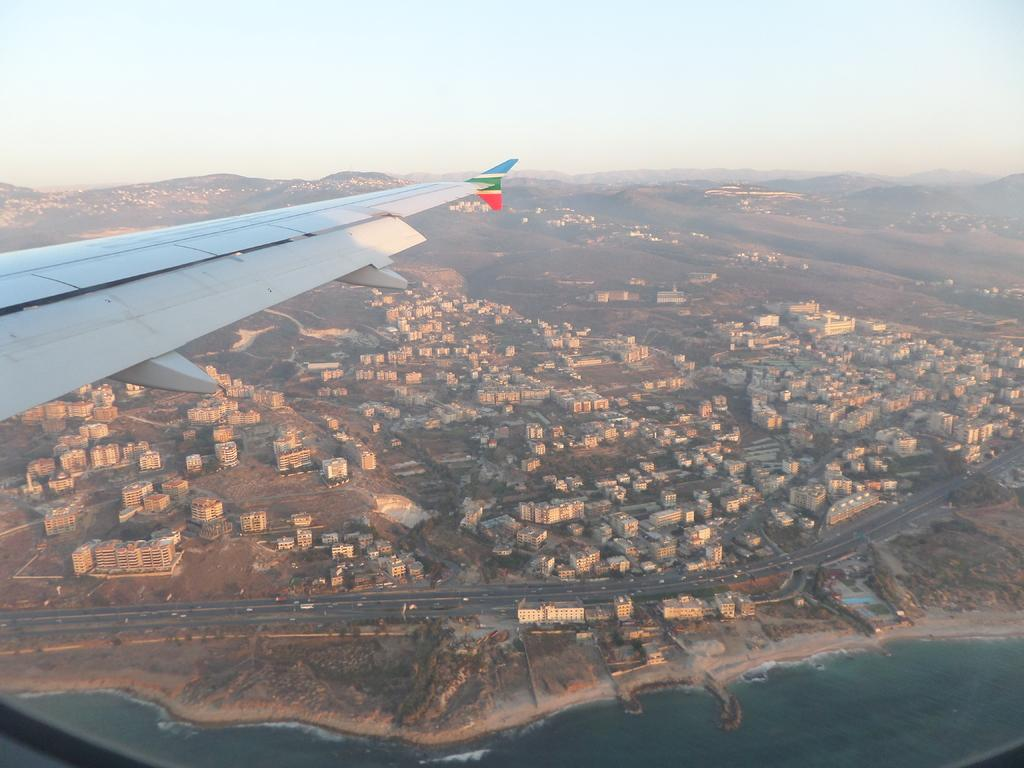What type of view is shown in the image? The image is a top view. What is flying in the image? There is an airplane flying in the image. What structures can be seen in the image? There are buildings in the image. What type of transportation is on the road in the image? There are vehicles on the road in the image. What natural features are present in the image? There are mountains in the image. What body of water is visible in the image? There is water visible in the image. What can be seen in the background of the image? The sky is visible in the background of the image. What type of teeth can be seen in the image? There are no teeth visible in the image. What selection of keys is available in the image? There is no mention of keys in the image. 